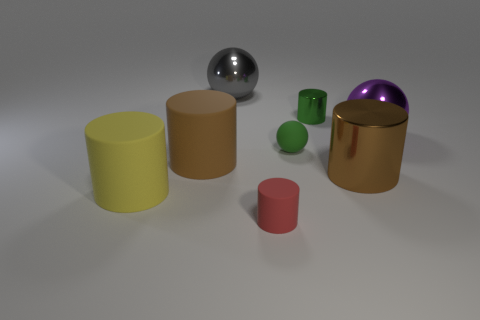Subtract all green metallic cylinders. How many cylinders are left? 4 Subtract all brown balls. How many brown cylinders are left? 2 Subtract all red cylinders. How many cylinders are left? 4 Subtract 3 cylinders. How many cylinders are left? 2 Add 1 cyan cylinders. How many objects exist? 9 Subtract all red cylinders. Subtract all cyan blocks. How many cylinders are left? 4 Add 4 purple spheres. How many purple spheres are left? 5 Add 1 purple shiny spheres. How many purple shiny spheres exist? 2 Subtract 0 blue spheres. How many objects are left? 8 Subtract all spheres. How many objects are left? 5 